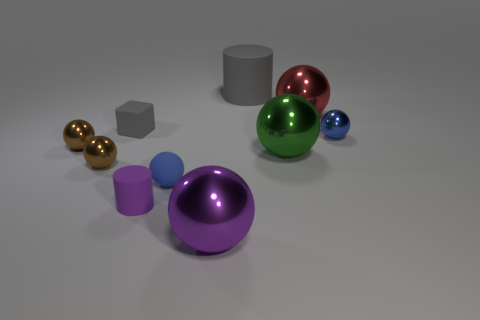Do the purple matte object and the blue metallic ball have the same size?
Keep it short and to the point. Yes. The small matte thing that is both right of the small matte cube and behind the small rubber cylinder is what color?
Provide a short and direct response. Blue. What number of small gray cubes have the same material as the green thing?
Provide a short and direct response. 0. How many big spheres are there?
Make the answer very short. 3. Is the size of the purple cylinder the same as the rubber object behind the small matte block?
Keep it short and to the point. No. There is a ball that is behind the small sphere right of the big purple metal ball; what is it made of?
Keep it short and to the point. Metal. There is a metal sphere that is behind the small blue thing that is right of the large ball that is in front of the tiny cylinder; what is its size?
Provide a short and direct response. Large. There is a large gray object; is it the same shape as the purple thing that is behind the purple metallic ball?
Offer a very short reply. Yes. What is the material of the big purple sphere?
Your response must be concise. Metal. What number of metallic objects are either large gray spheres or tiny brown things?
Offer a very short reply. 2. 